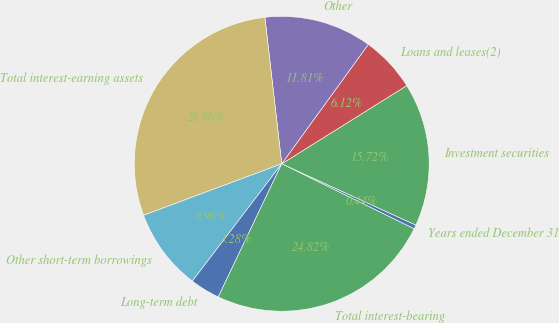Convert chart to OTSL. <chart><loc_0><loc_0><loc_500><loc_500><pie_chart><fcel>Years ended December 31<fcel>Investment securities<fcel>Loans and leases(2)<fcel>Other<fcel>Total interest-earning assets<fcel>Other short-term borrowings<fcel>Long-term debt<fcel>Total interest-bearing<nl><fcel>0.44%<fcel>15.72%<fcel>6.12%<fcel>11.81%<fcel>28.86%<fcel>8.96%<fcel>3.28%<fcel>24.82%<nl></chart> 